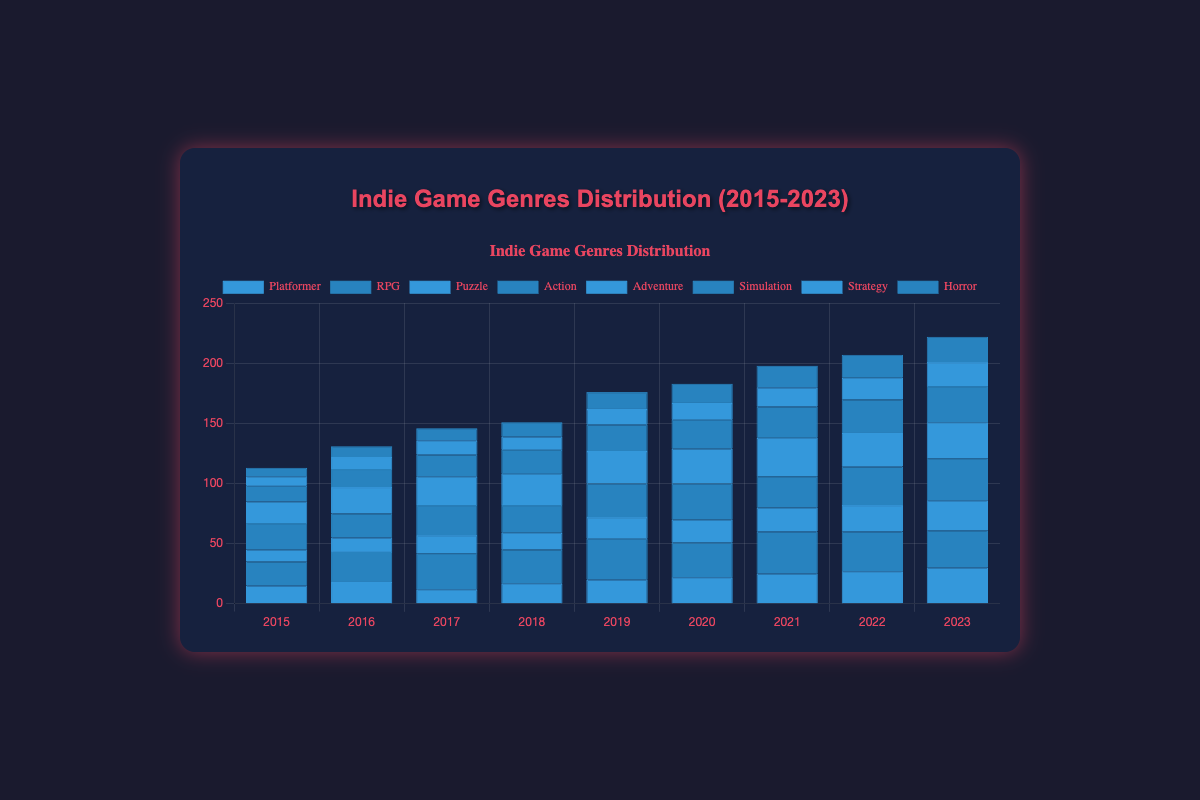What is the overall trend of RPG genre games from 2015 to 2023? To determine the trend, observe the RPG genre bars for each year from 2015 to 2023. Notice if the trend is an increase, decrease, or remains stable. From the data, the RPG genre starts at 20 games in 2015 and fluctuates but generally increases to 31 games in 2023.
Answer: Increasing Which year had the highest number of Action genre games? To find this, identify the tallest bar for the Action genre, which is represented by the dark blue color, from 2015 to 2023. The tallest bar occurs in 2023 with 35 games.
Answer: 2023 How do the number of Platformer games in 2018 compare to Puzzle games in the same year? Look at the height of both the Platformer and Puzzle bars for the year 2018. The Platformer games have a count of 17, while Puzzle games have a count of 14.
Answer: Platformer had more games than Puzzle in 2018 What is the average number of Simulation genre games from 2015 to 2023? First, sum the total number of Simulation games from 2015 to 2023: 13 + 15 + 18 + 20 + 22 + 24 + 26 + 28 + 30 = 196. Then divide the total by the number of years, which is 9. 196 / 9 = 21.78
Answer: 21.78 Did the number of Strategy games ever surpass 20 in any year? Check the bar heights for Strategy games for each year from 2015 to 2023. The counts for Strategy are 8, 10, 12, 11, 13, 14, 16, 18, and 20. None of these numbers surpass 20.
Answer: No In which years did the number of Platformer genre games exceed the number of Adventure genre games? Compare the heights of Platformer and Adventure genre bars for each year. The counts for Platformer are: 15, 18, 12, 17, 20, 22, 25, 27, 30. The counts for Adventure are: 18, 22, 24, 26, 27, 29, 32, 28, 30. Platformer exceeds Adventure in 2015, 2018, 2022, and 2023.
Answer: 2015, 2018, 2022, 2023 What's the difference between the highest and lowest counts for the Horror genre from 2015 to 2023? Determine the highest and lowest counts for Horror: highest is 21 (2023), lowest is 7 (2015). The difference is 21 - 7 = 14.
Answer: 14 In 2020, which genre had the smallest number of games? Examine the bar heights for each genre in 2020 and identify the shortest bar. The counts are Platformer: 22, RPG: 29, Puzzle: 19, Action: 30, Adventure: 29, Simulation: 24, Strategy: 14, Horror: 16. The shortest bar is for Strategy, with 14 games.
Answer: Strategy How many total Adventure genre games were tracked from 2015 to 2023? Sum the count of Adventure games for each year: 18 + 22 + 24 + 26 + 27 + 29 + 32 + 28 + 30 = 236.
Answer: 236 For the year 2019, how many more Action genre games were there compared to Simulation genre games? Identify the counts for Action and Simulation in 2019. Action is 28 and Simulation is 22. The difference is 28 - 22 = 6.
Answer: 6 